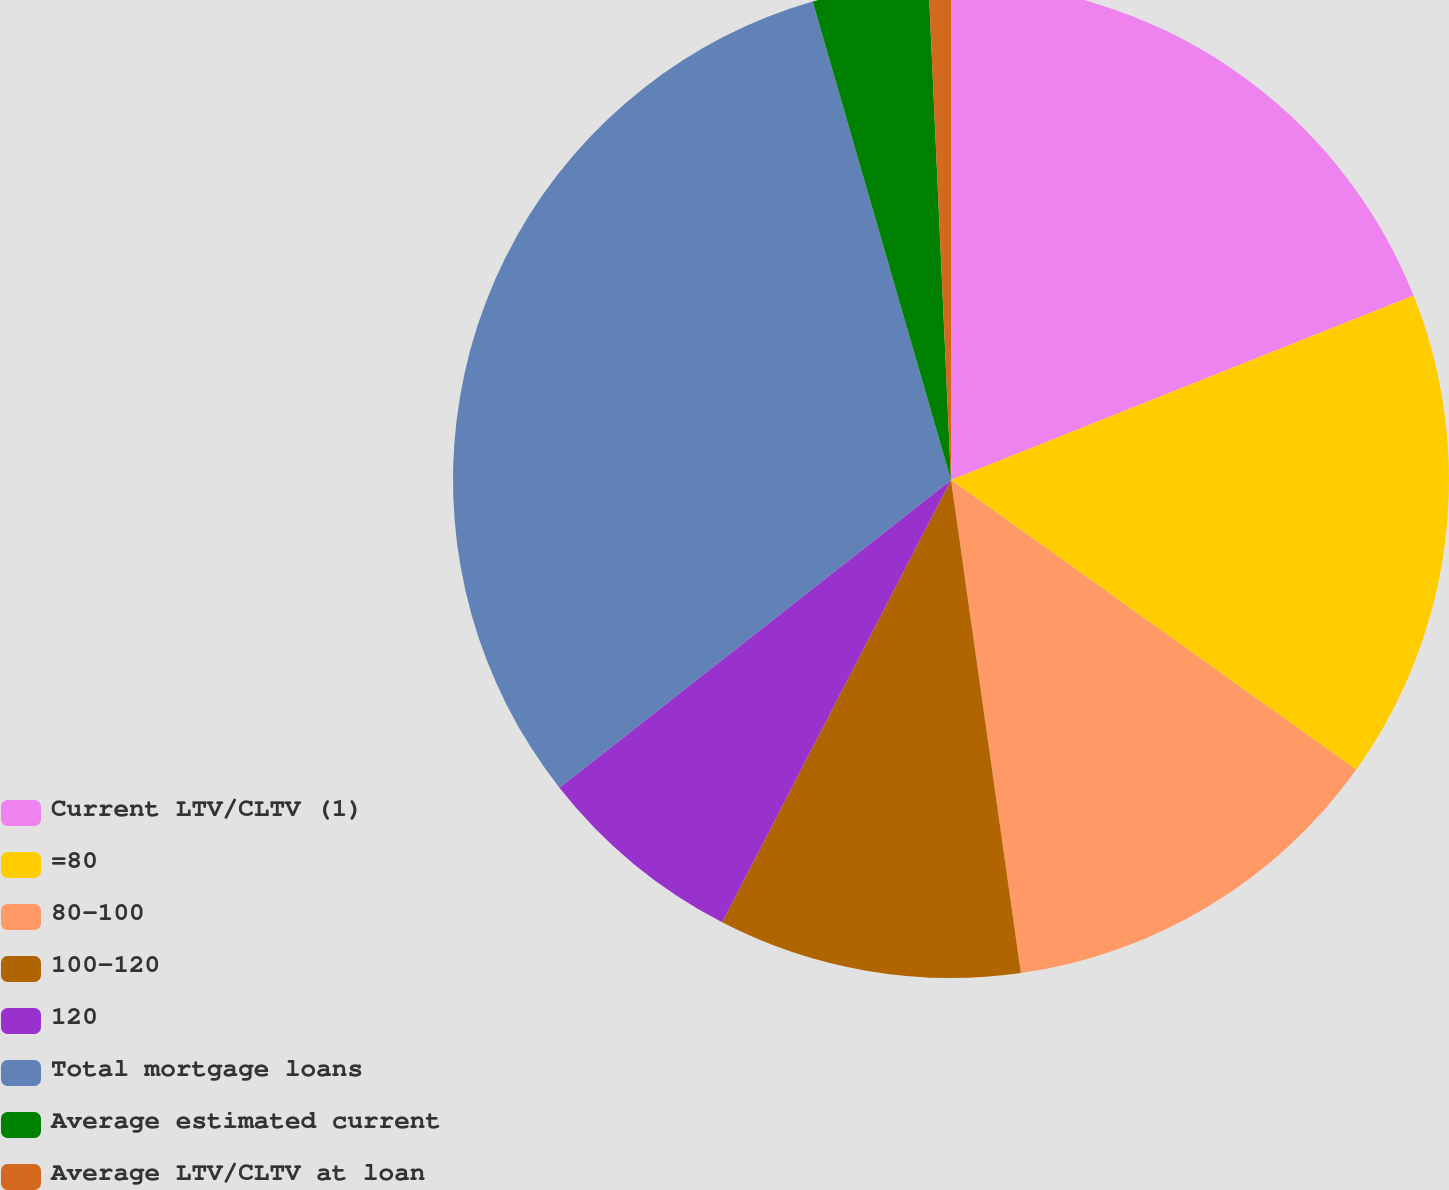Convert chart. <chart><loc_0><loc_0><loc_500><loc_500><pie_chart><fcel>Current LTV/CLTV (1)<fcel>=80<fcel>80-100<fcel>100-120<fcel>120<fcel>Total mortgage loans<fcel>Average estimated current<fcel>Average LTV/CLTV at loan<nl><fcel>18.96%<fcel>15.92%<fcel>12.88%<fcel>9.84%<fcel>6.8%<fcel>31.12%<fcel>3.76%<fcel>0.72%<nl></chart> 